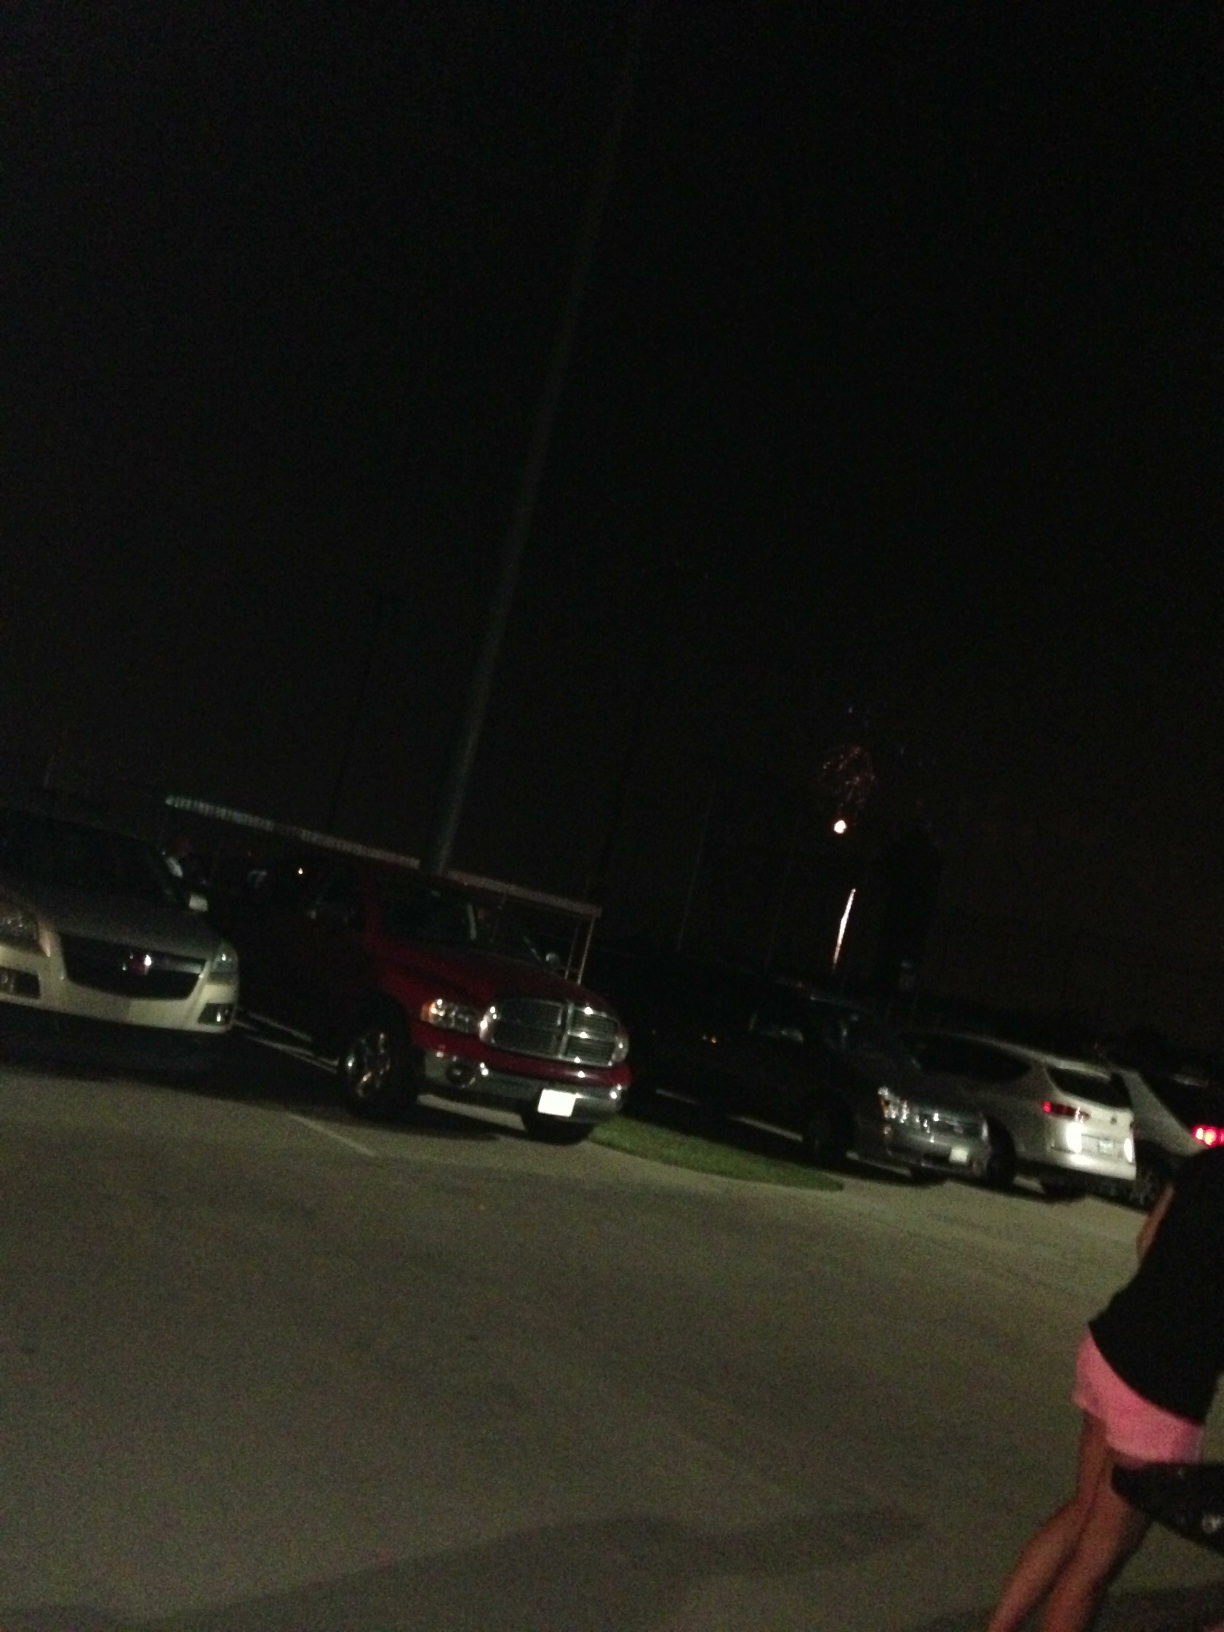What does it look like out here? The scene is quite dark, with only a few sources of light illuminating the area. It appears to be a crowded parking lot at night, and there's a visible firework in the sky, suggesting some kind of celebration or event might be happening nearby. 